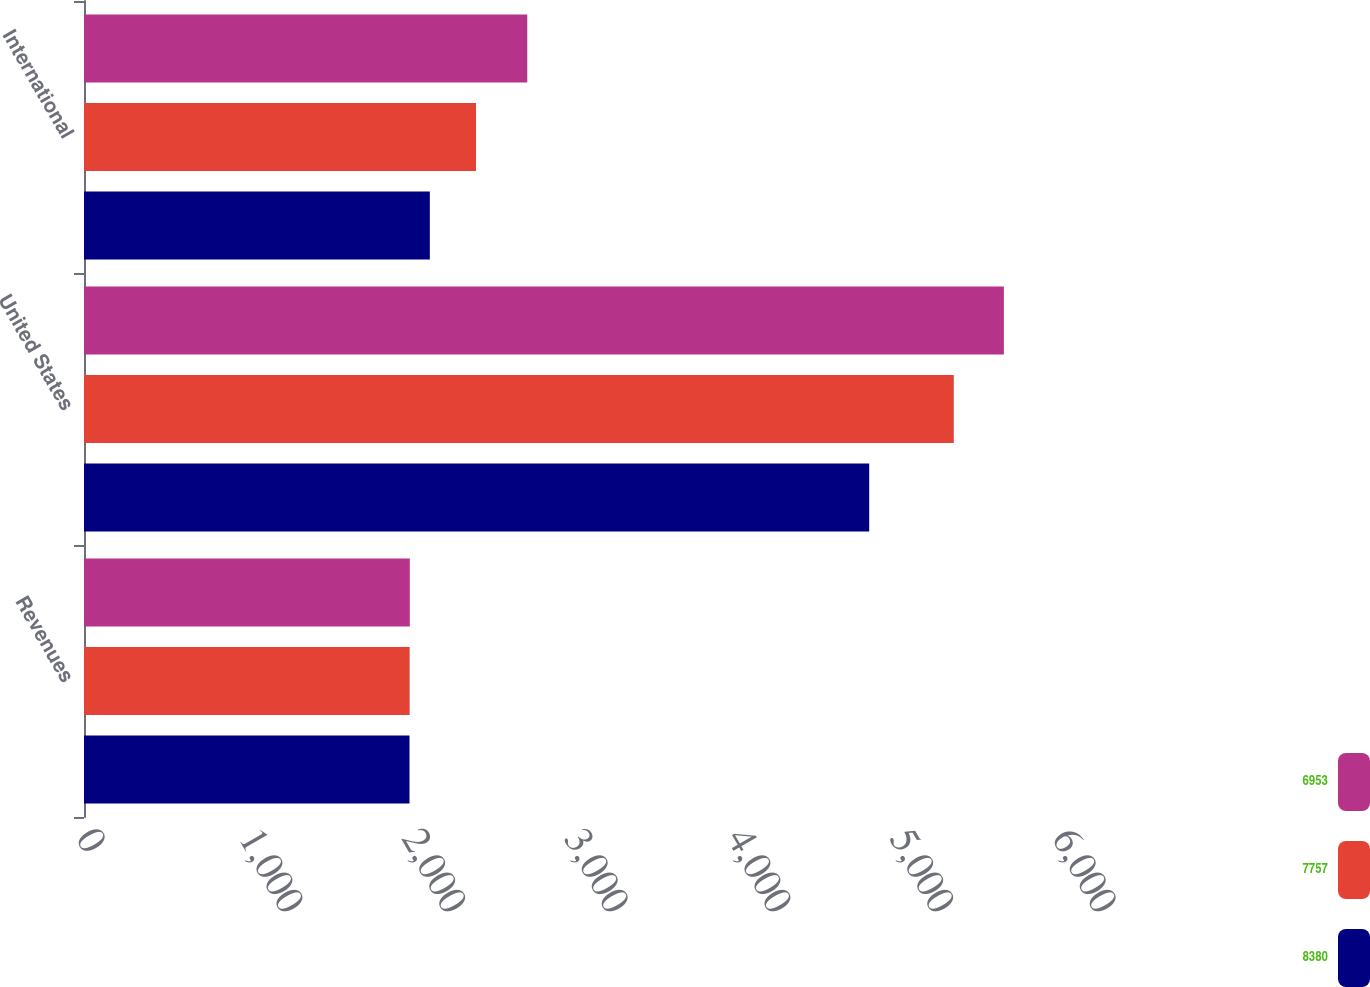<chart> <loc_0><loc_0><loc_500><loc_500><stacked_bar_chart><ecel><fcel>Revenues<fcel>United States<fcel>International<nl><fcel>6953<fcel>2003<fcel>5655<fcel>2725<nl><fcel>7757<fcel>2002<fcel>5347<fcel>2410<nl><fcel>8380<fcel>2001<fcel>4827<fcel>2126<nl></chart> 